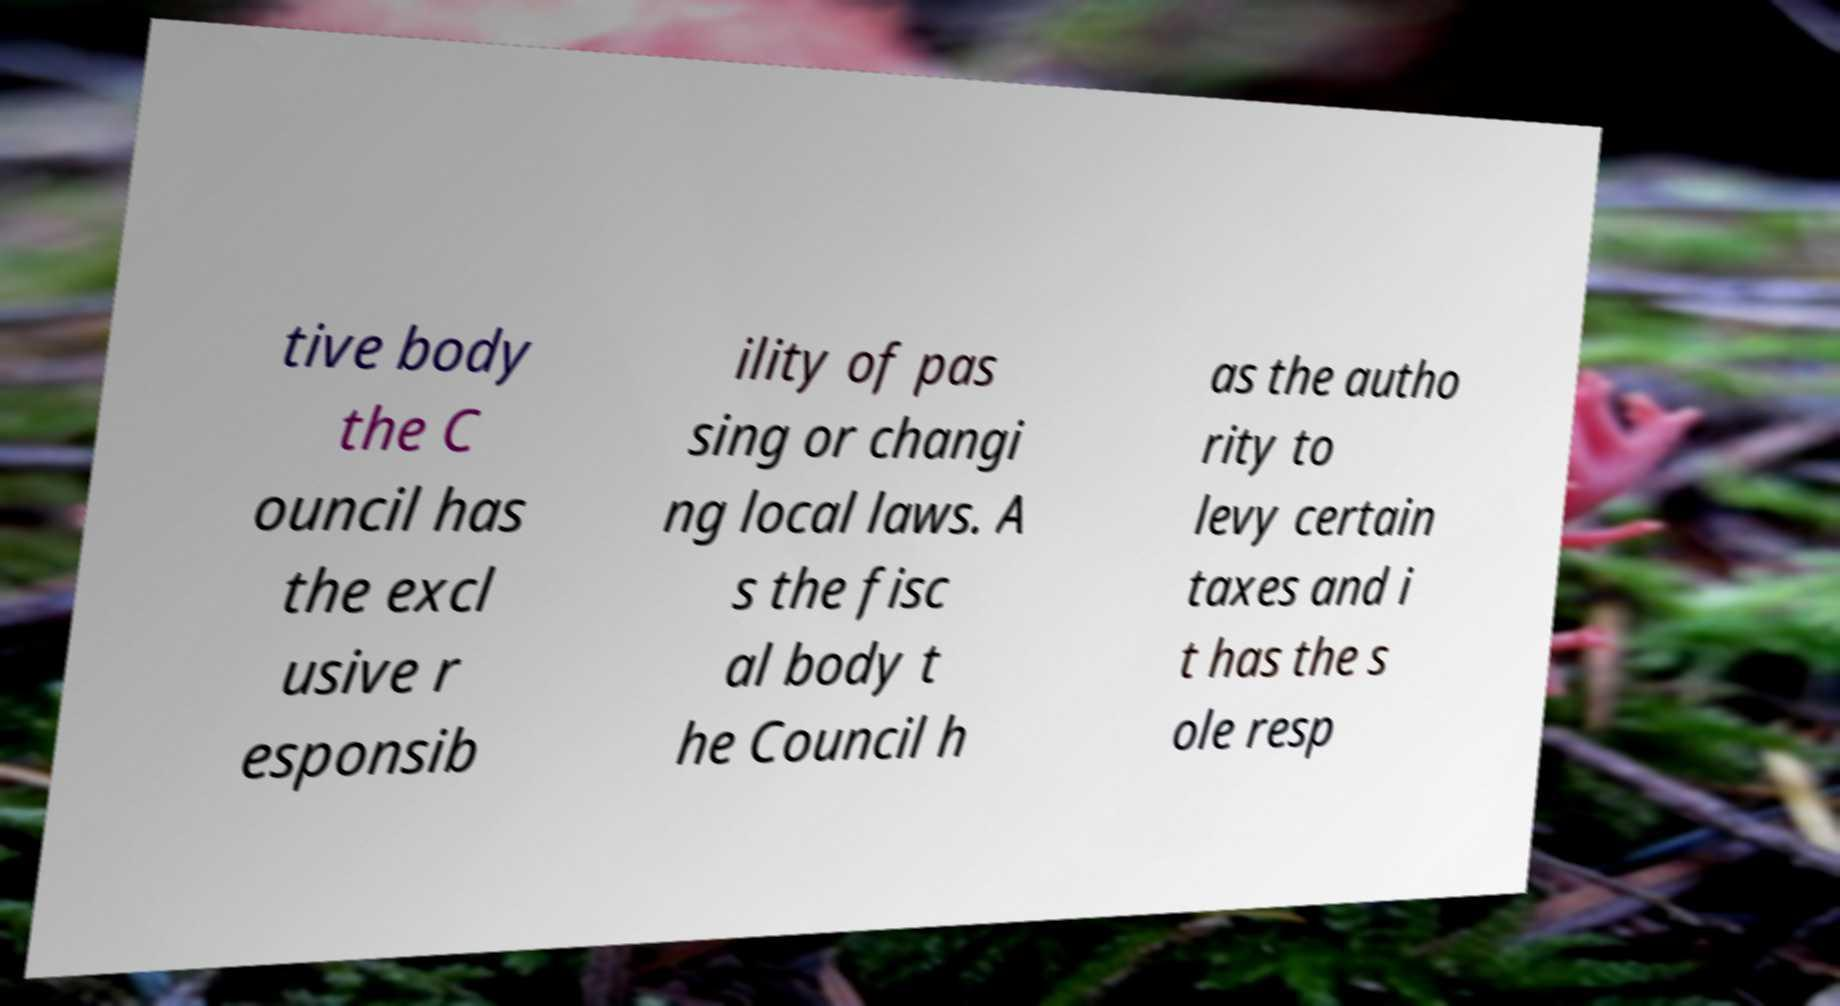Could you assist in decoding the text presented in this image and type it out clearly? tive body the C ouncil has the excl usive r esponsib ility of pas sing or changi ng local laws. A s the fisc al body t he Council h as the autho rity to levy certain taxes and i t has the s ole resp 